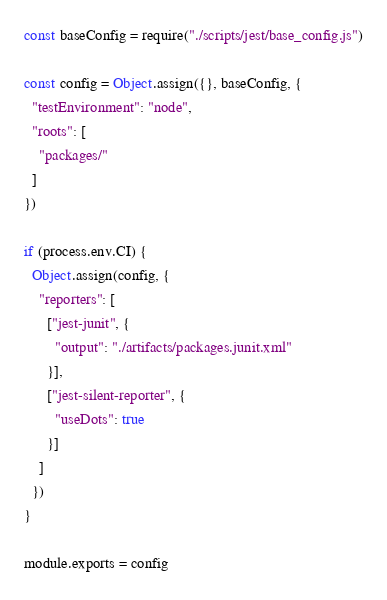<code> <loc_0><loc_0><loc_500><loc_500><_JavaScript_>const baseConfig = require("./scripts/jest/base_config.js")

const config = Object.assign({}, baseConfig, {
  "testEnvironment": "node",
  "roots": [
    "packages/"
  ]
})

if (process.env.CI) {
  Object.assign(config, {
    "reporters": [
      ["jest-junit", {
        "output": "./artifacts/packages.junit.xml"
      }],
      ["jest-silent-reporter", {
        "useDots": true
      }]
    ]
  })
}

module.exports = config
</code> 